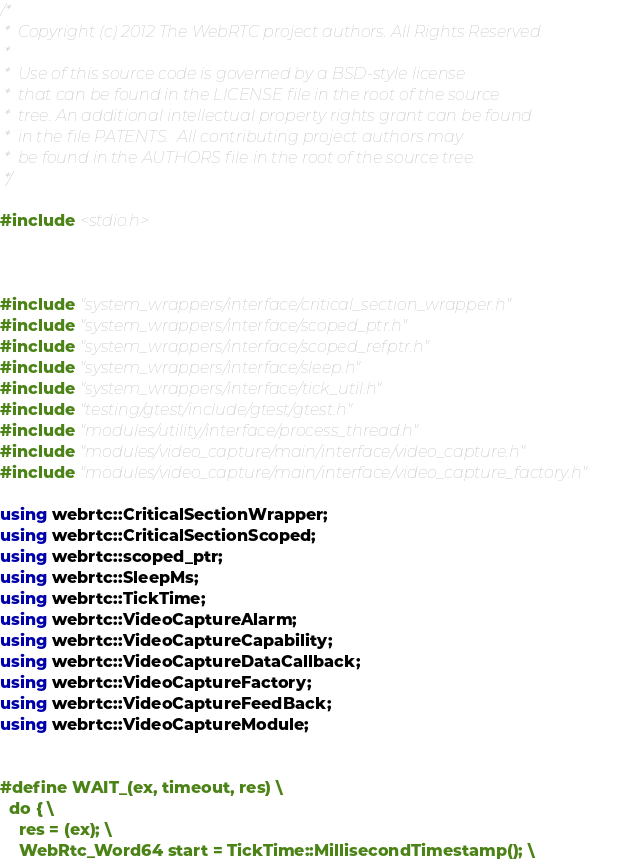Convert code to text. <code><loc_0><loc_0><loc_500><loc_500><_C++_>/*
 *  Copyright (c) 2012 The WebRTC project authors. All Rights Reserved.
 *
 *  Use of this source code is governed by a BSD-style license
 *  that can be found in the LICENSE file in the root of the source
 *  tree. An additional intellectual property rights grant can be found
 *  in the file PATENTS.  All contributing project authors may
 *  be found in the AUTHORS file in the root of the source tree.
 */

#include <stdio.h>



#include "system_wrappers/interface/critical_section_wrapper.h"
#include "system_wrappers/interface/scoped_ptr.h"
#include "system_wrappers/interface/scoped_refptr.h"
#include "system_wrappers/interface/sleep.h"
#include "system_wrappers/interface/tick_util.h"
#include "testing/gtest/include/gtest/gtest.h"
#include "modules/utility/interface/process_thread.h"
#include "modules/video_capture/main/interface/video_capture.h"
#include "modules/video_capture/main/interface/video_capture_factory.h"

using webrtc::CriticalSectionWrapper;
using webrtc::CriticalSectionScoped;
using webrtc::scoped_ptr;
using webrtc::SleepMs;
using webrtc::TickTime;
using webrtc::VideoCaptureAlarm;
using webrtc::VideoCaptureCapability;
using webrtc::VideoCaptureDataCallback;
using webrtc::VideoCaptureFactory;
using webrtc::VideoCaptureFeedBack;
using webrtc::VideoCaptureModule;


#define WAIT_(ex, timeout, res) \
  do { \
    res = (ex); \
    WebRtc_Word64 start = TickTime::MillisecondTimestamp(); \</code> 